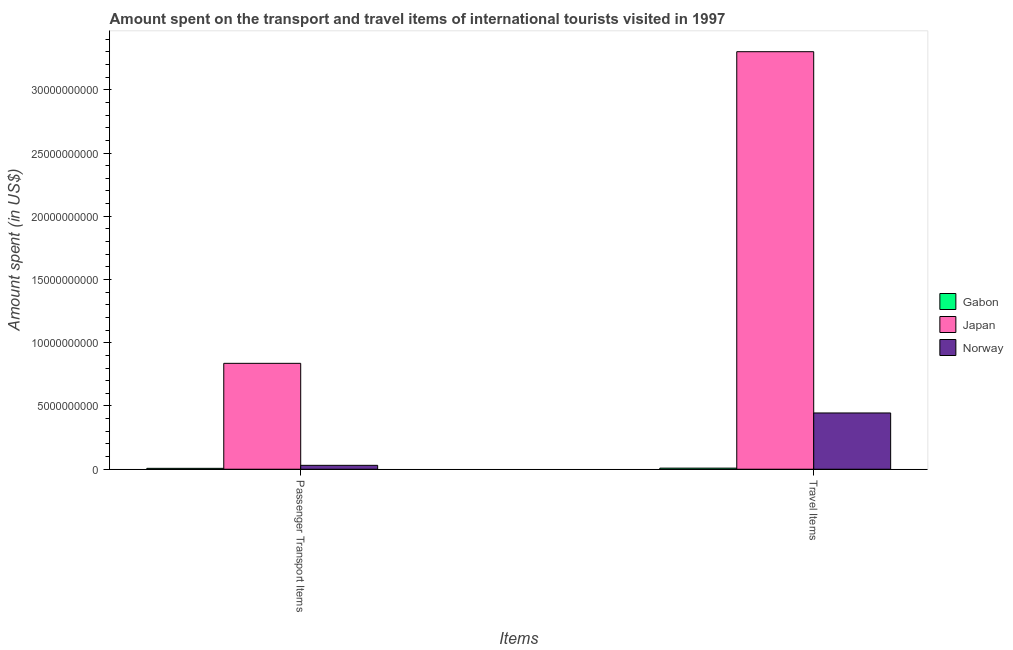Are the number of bars per tick equal to the number of legend labels?
Provide a succinct answer. Yes. How many bars are there on the 2nd tick from the right?
Offer a very short reply. 3. What is the label of the 2nd group of bars from the left?
Your answer should be compact. Travel Items. What is the amount spent on passenger transport items in Japan?
Provide a succinct answer. 8.37e+09. Across all countries, what is the maximum amount spent in travel items?
Keep it short and to the point. 3.30e+1. Across all countries, what is the minimum amount spent in travel items?
Offer a terse response. 8.60e+07. In which country was the amount spent on passenger transport items minimum?
Offer a very short reply. Gabon. What is the total amount spent in travel items in the graph?
Ensure brevity in your answer.  3.75e+1. What is the difference between the amount spent on passenger transport items in Gabon and that in Norway?
Offer a very short reply. -2.38e+08. What is the difference between the amount spent on passenger transport items in Norway and the amount spent in travel items in Japan?
Your answer should be compact. -3.27e+1. What is the average amount spent in travel items per country?
Provide a short and direct response. 1.25e+1. What is the difference between the amount spent on passenger transport items and amount spent in travel items in Gabon?
Offer a terse response. -1.60e+07. In how many countries, is the amount spent on passenger transport items greater than 7000000000 US$?
Your response must be concise. 1. What is the ratio of the amount spent on passenger transport items in Norway to that in Gabon?
Provide a succinct answer. 4.4. What does the 1st bar from the left in Passenger Transport Items represents?
Make the answer very short. Gabon. What does the 3rd bar from the right in Travel Items represents?
Offer a very short reply. Gabon. How many bars are there?
Ensure brevity in your answer.  6. How many countries are there in the graph?
Ensure brevity in your answer.  3. What is the difference between two consecutive major ticks on the Y-axis?
Give a very brief answer. 5.00e+09. Does the graph contain any zero values?
Your answer should be compact. No. Where does the legend appear in the graph?
Keep it short and to the point. Center right. How many legend labels are there?
Ensure brevity in your answer.  3. How are the legend labels stacked?
Provide a succinct answer. Vertical. What is the title of the graph?
Make the answer very short. Amount spent on the transport and travel items of international tourists visited in 1997. Does "Dominican Republic" appear as one of the legend labels in the graph?
Make the answer very short. No. What is the label or title of the X-axis?
Provide a short and direct response. Items. What is the label or title of the Y-axis?
Offer a very short reply. Amount spent (in US$). What is the Amount spent (in US$) in Gabon in Passenger Transport Items?
Offer a very short reply. 7.00e+07. What is the Amount spent (in US$) in Japan in Passenger Transport Items?
Offer a terse response. 8.37e+09. What is the Amount spent (in US$) in Norway in Passenger Transport Items?
Make the answer very short. 3.08e+08. What is the Amount spent (in US$) of Gabon in Travel Items?
Your response must be concise. 8.60e+07. What is the Amount spent (in US$) in Japan in Travel Items?
Your answer should be very brief. 3.30e+1. What is the Amount spent (in US$) in Norway in Travel Items?
Your response must be concise. 4.45e+09. Across all Items, what is the maximum Amount spent (in US$) of Gabon?
Offer a terse response. 8.60e+07. Across all Items, what is the maximum Amount spent (in US$) of Japan?
Give a very brief answer. 3.30e+1. Across all Items, what is the maximum Amount spent (in US$) in Norway?
Offer a terse response. 4.45e+09. Across all Items, what is the minimum Amount spent (in US$) of Gabon?
Your response must be concise. 7.00e+07. Across all Items, what is the minimum Amount spent (in US$) in Japan?
Make the answer very short. 8.37e+09. Across all Items, what is the minimum Amount spent (in US$) in Norway?
Your response must be concise. 3.08e+08. What is the total Amount spent (in US$) in Gabon in the graph?
Make the answer very short. 1.56e+08. What is the total Amount spent (in US$) in Japan in the graph?
Your answer should be very brief. 4.14e+1. What is the total Amount spent (in US$) in Norway in the graph?
Offer a very short reply. 4.76e+09. What is the difference between the Amount spent (in US$) of Gabon in Passenger Transport Items and that in Travel Items?
Your response must be concise. -1.60e+07. What is the difference between the Amount spent (in US$) in Japan in Passenger Transport Items and that in Travel Items?
Ensure brevity in your answer.  -2.46e+1. What is the difference between the Amount spent (in US$) of Norway in Passenger Transport Items and that in Travel Items?
Offer a very short reply. -4.14e+09. What is the difference between the Amount spent (in US$) of Gabon in Passenger Transport Items and the Amount spent (in US$) of Japan in Travel Items?
Give a very brief answer. -3.29e+1. What is the difference between the Amount spent (in US$) of Gabon in Passenger Transport Items and the Amount spent (in US$) of Norway in Travel Items?
Your answer should be very brief. -4.38e+09. What is the difference between the Amount spent (in US$) in Japan in Passenger Transport Items and the Amount spent (in US$) in Norway in Travel Items?
Your answer should be compact. 3.92e+09. What is the average Amount spent (in US$) in Gabon per Items?
Your answer should be very brief. 7.80e+07. What is the average Amount spent (in US$) in Japan per Items?
Make the answer very short. 2.07e+1. What is the average Amount spent (in US$) of Norway per Items?
Offer a terse response. 2.38e+09. What is the difference between the Amount spent (in US$) of Gabon and Amount spent (in US$) of Japan in Passenger Transport Items?
Offer a very short reply. -8.30e+09. What is the difference between the Amount spent (in US$) in Gabon and Amount spent (in US$) in Norway in Passenger Transport Items?
Ensure brevity in your answer.  -2.38e+08. What is the difference between the Amount spent (in US$) of Japan and Amount spent (in US$) of Norway in Passenger Transport Items?
Provide a succinct answer. 8.06e+09. What is the difference between the Amount spent (in US$) in Gabon and Amount spent (in US$) in Japan in Travel Items?
Offer a terse response. -3.29e+1. What is the difference between the Amount spent (in US$) in Gabon and Amount spent (in US$) in Norway in Travel Items?
Offer a very short reply. -4.36e+09. What is the difference between the Amount spent (in US$) of Japan and Amount spent (in US$) of Norway in Travel Items?
Offer a very short reply. 2.86e+1. What is the ratio of the Amount spent (in US$) of Gabon in Passenger Transport Items to that in Travel Items?
Offer a very short reply. 0.81. What is the ratio of the Amount spent (in US$) of Japan in Passenger Transport Items to that in Travel Items?
Your response must be concise. 0.25. What is the ratio of the Amount spent (in US$) in Norway in Passenger Transport Items to that in Travel Items?
Make the answer very short. 0.07. What is the difference between the highest and the second highest Amount spent (in US$) of Gabon?
Offer a very short reply. 1.60e+07. What is the difference between the highest and the second highest Amount spent (in US$) in Japan?
Keep it short and to the point. 2.46e+1. What is the difference between the highest and the second highest Amount spent (in US$) in Norway?
Make the answer very short. 4.14e+09. What is the difference between the highest and the lowest Amount spent (in US$) of Gabon?
Your response must be concise. 1.60e+07. What is the difference between the highest and the lowest Amount spent (in US$) of Japan?
Make the answer very short. 2.46e+1. What is the difference between the highest and the lowest Amount spent (in US$) of Norway?
Offer a very short reply. 4.14e+09. 